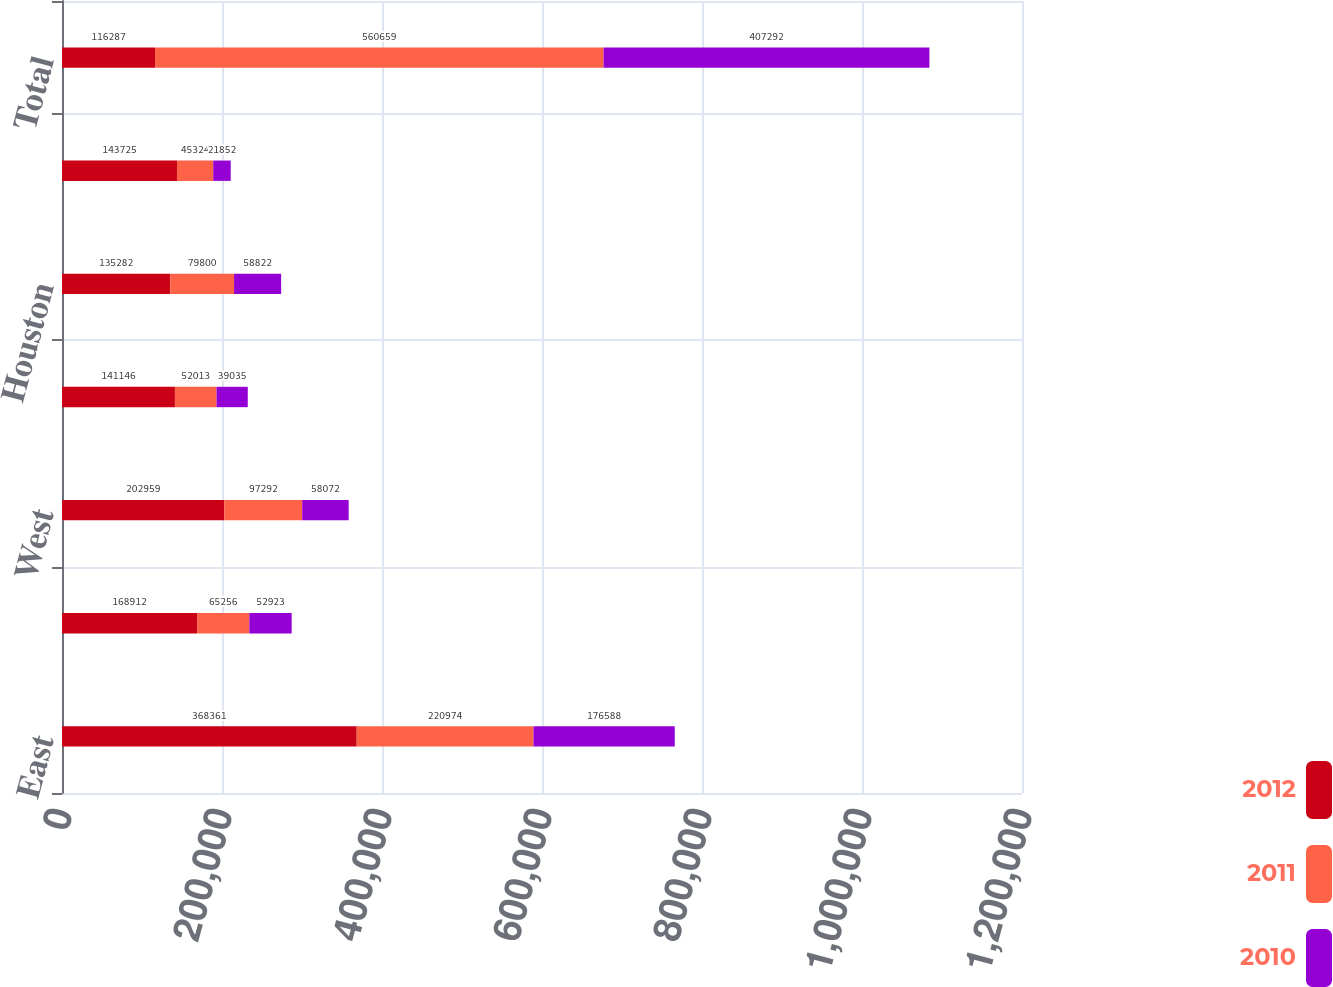<chart> <loc_0><loc_0><loc_500><loc_500><stacked_bar_chart><ecel><fcel>East<fcel>Central<fcel>West<fcel>Southeast Florida<fcel>Houston<fcel>Other<fcel>Total<nl><fcel>2012<fcel>368361<fcel>168912<fcel>202959<fcel>141146<fcel>135282<fcel>143725<fcel>116287<nl><fcel>2011<fcel>220974<fcel>65256<fcel>97292<fcel>52013<fcel>79800<fcel>45324<fcel>560659<nl><fcel>2010<fcel>176588<fcel>52923<fcel>58072<fcel>39035<fcel>58822<fcel>21852<fcel>407292<nl></chart> 